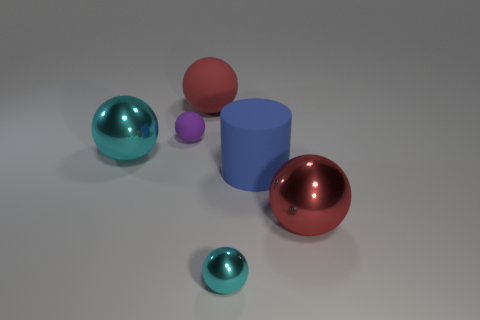Subtract all cyan shiny spheres. How many spheres are left? 3 Subtract all brown cylinders. How many cyan spheres are left? 2 Subtract all red spheres. How many spheres are left? 3 Subtract all balls. How many objects are left? 1 Add 3 big cyan blocks. How many objects exist? 9 Subtract 1 cylinders. How many cylinders are left? 0 Add 2 blue objects. How many blue objects exist? 3 Subtract 0 blue cubes. How many objects are left? 6 Subtract all gray cylinders. Subtract all blue spheres. How many cylinders are left? 1 Subtract all tiny brown cubes. Subtract all tiny matte spheres. How many objects are left? 5 